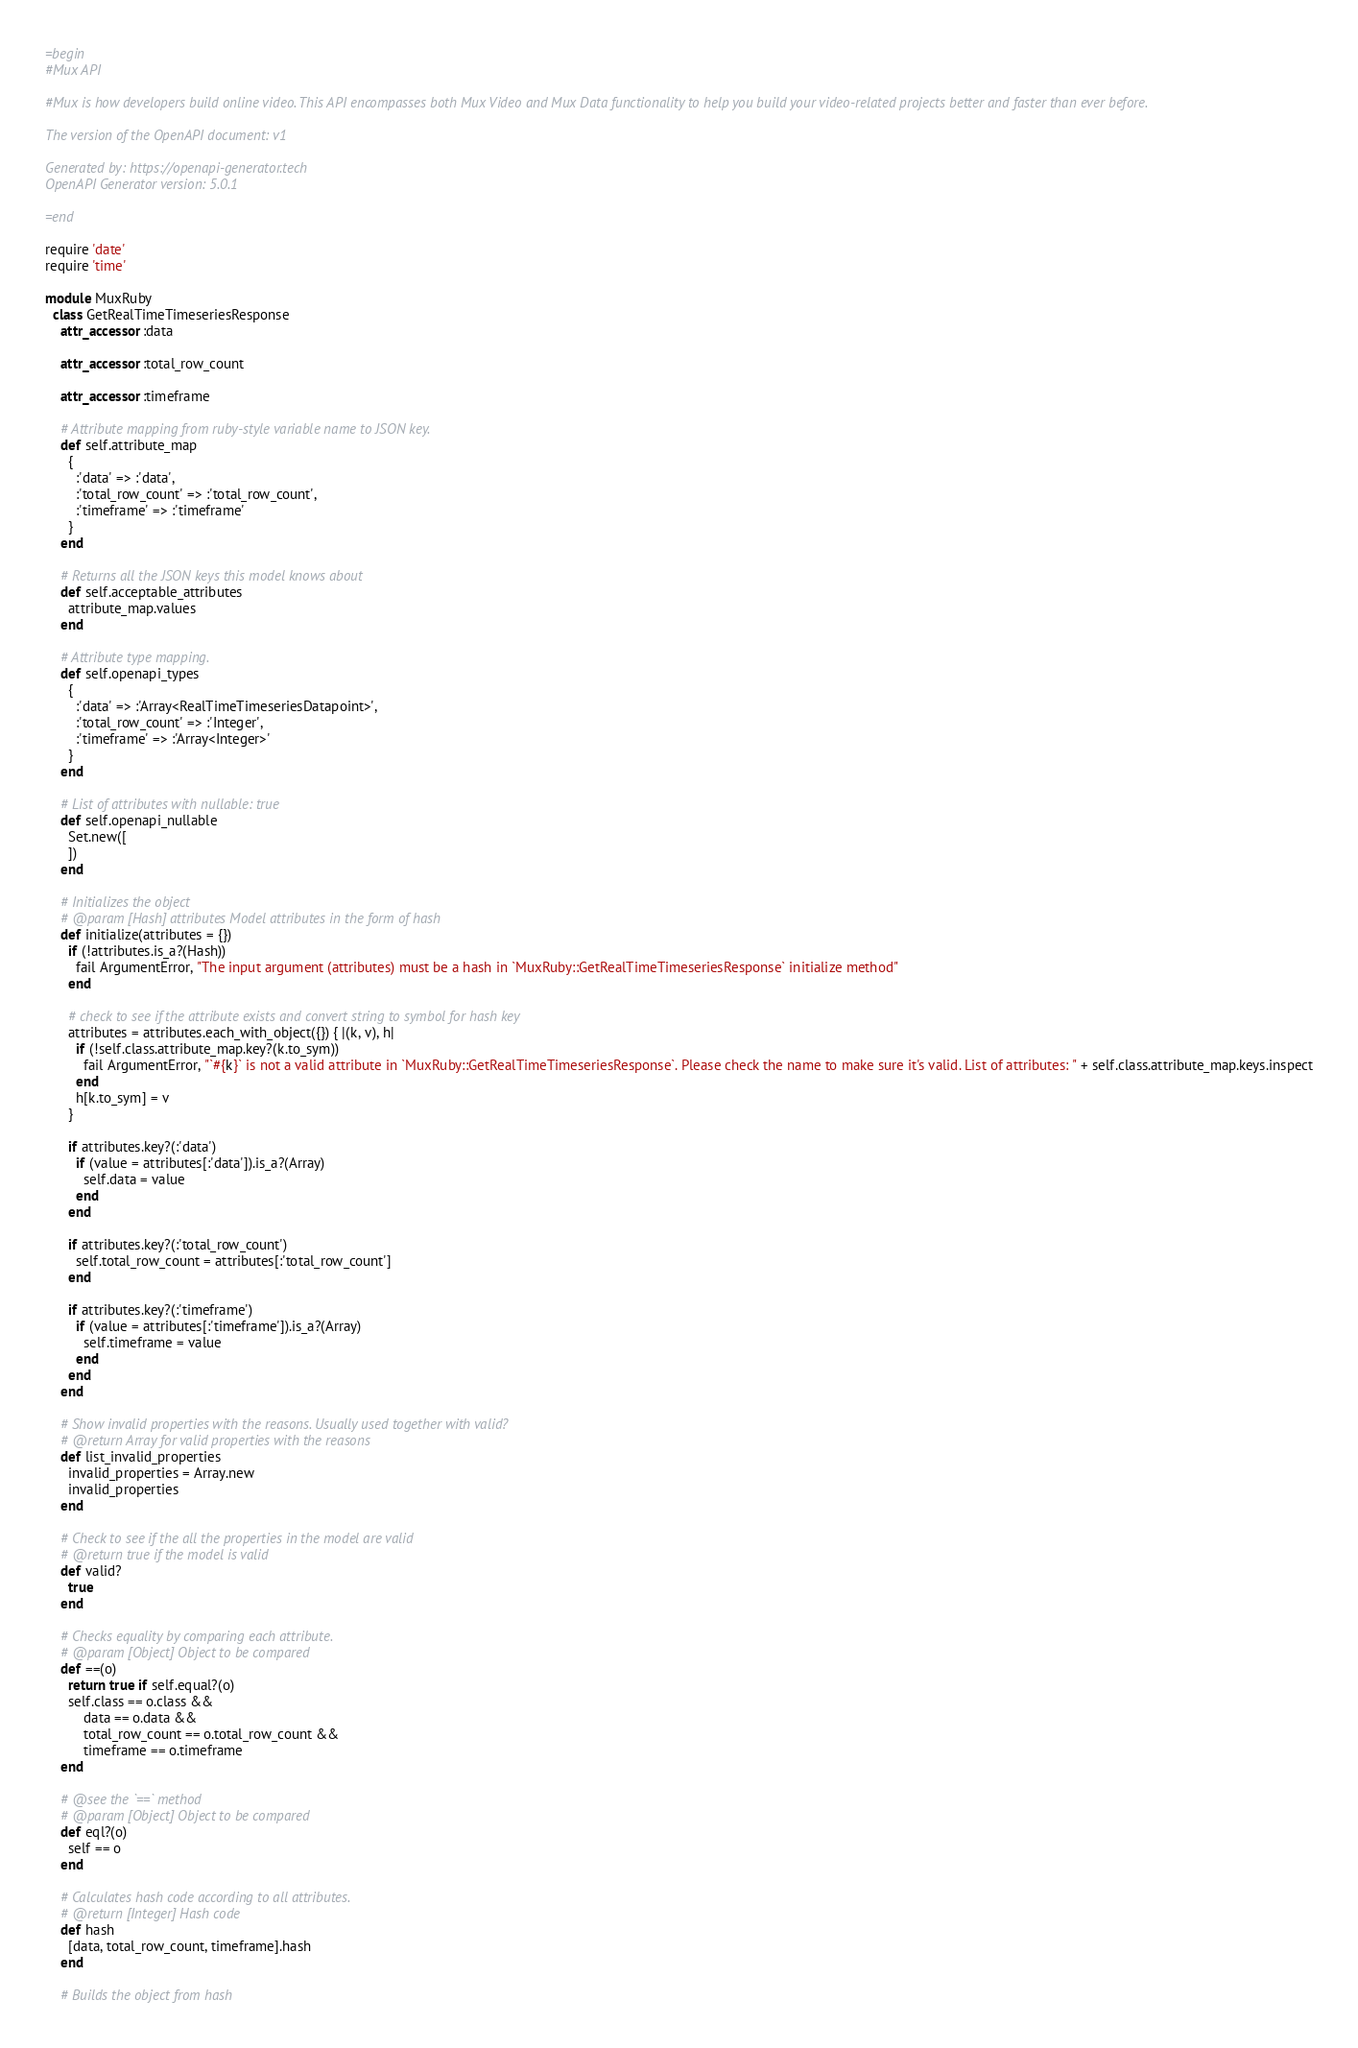<code> <loc_0><loc_0><loc_500><loc_500><_Ruby_>=begin
#Mux API

#Mux is how developers build online video. This API encompasses both Mux Video and Mux Data functionality to help you build your video-related projects better and faster than ever before. 

The version of the OpenAPI document: v1

Generated by: https://openapi-generator.tech
OpenAPI Generator version: 5.0.1

=end

require 'date'
require 'time'

module MuxRuby
  class GetRealTimeTimeseriesResponse
    attr_accessor :data

    attr_accessor :total_row_count

    attr_accessor :timeframe

    # Attribute mapping from ruby-style variable name to JSON key.
    def self.attribute_map
      {
        :'data' => :'data',
        :'total_row_count' => :'total_row_count',
        :'timeframe' => :'timeframe'
      }
    end

    # Returns all the JSON keys this model knows about
    def self.acceptable_attributes
      attribute_map.values
    end

    # Attribute type mapping.
    def self.openapi_types
      {
        :'data' => :'Array<RealTimeTimeseriesDatapoint>',
        :'total_row_count' => :'Integer',
        :'timeframe' => :'Array<Integer>'
      }
    end

    # List of attributes with nullable: true
    def self.openapi_nullable
      Set.new([
      ])
    end

    # Initializes the object
    # @param [Hash] attributes Model attributes in the form of hash
    def initialize(attributes = {})
      if (!attributes.is_a?(Hash))
        fail ArgumentError, "The input argument (attributes) must be a hash in `MuxRuby::GetRealTimeTimeseriesResponse` initialize method"
      end

      # check to see if the attribute exists and convert string to symbol for hash key
      attributes = attributes.each_with_object({}) { |(k, v), h|
        if (!self.class.attribute_map.key?(k.to_sym))
          fail ArgumentError, "`#{k}` is not a valid attribute in `MuxRuby::GetRealTimeTimeseriesResponse`. Please check the name to make sure it's valid. List of attributes: " + self.class.attribute_map.keys.inspect
        end
        h[k.to_sym] = v
      }

      if attributes.key?(:'data')
        if (value = attributes[:'data']).is_a?(Array)
          self.data = value
        end
      end

      if attributes.key?(:'total_row_count')
        self.total_row_count = attributes[:'total_row_count']
      end

      if attributes.key?(:'timeframe')
        if (value = attributes[:'timeframe']).is_a?(Array)
          self.timeframe = value
        end
      end
    end

    # Show invalid properties with the reasons. Usually used together with valid?
    # @return Array for valid properties with the reasons
    def list_invalid_properties
      invalid_properties = Array.new
      invalid_properties
    end

    # Check to see if the all the properties in the model are valid
    # @return true if the model is valid
    def valid?
      true
    end

    # Checks equality by comparing each attribute.
    # @param [Object] Object to be compared
    def ==(o)
      return true if self.equal?(o)
      self.class == o.class &&
          data == o.data &&
          total_row_count == o.total_row_count &&
          timeframe == o.timeframe
    end

    # @see the `==` method
    # @param [Object] Object to be compared
    def eql?(o)
      self == o
    end

    # Calculates hash code according to all attributes.
    # @return [Integer] Hash code
    def hash
      [data, total_row_count, timeframe].hash
    end

    # Builds the object from hash</code> 